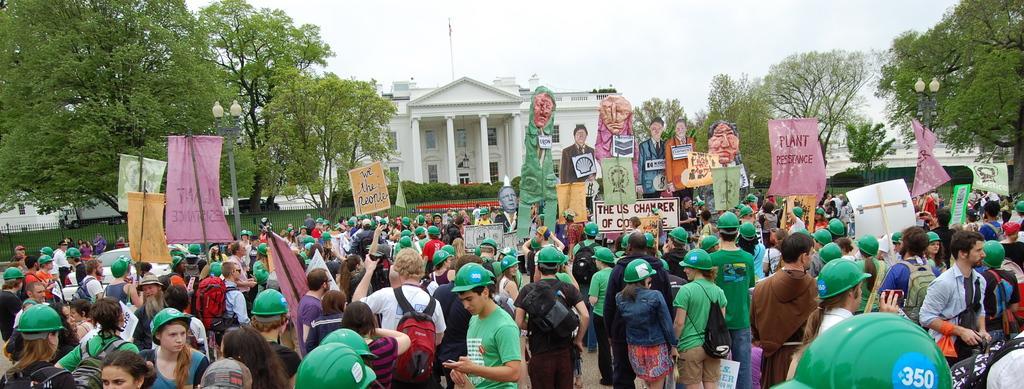Could you give a brief overview of what you see in this image? In this image, we can see persons wearing clothes and helmets. There are some persons holding banners with their hands. There are some plants in front of the building. There are some cutouts in the middle of the image. There are trees on the left and on the right side of the image. There are street poles in front of the fencing. There is a sky at the top of the image. 